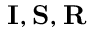Convert formula to latex. <formula><loc_0><loc_0><loc_500><loc_500>I , S , R</formula> 